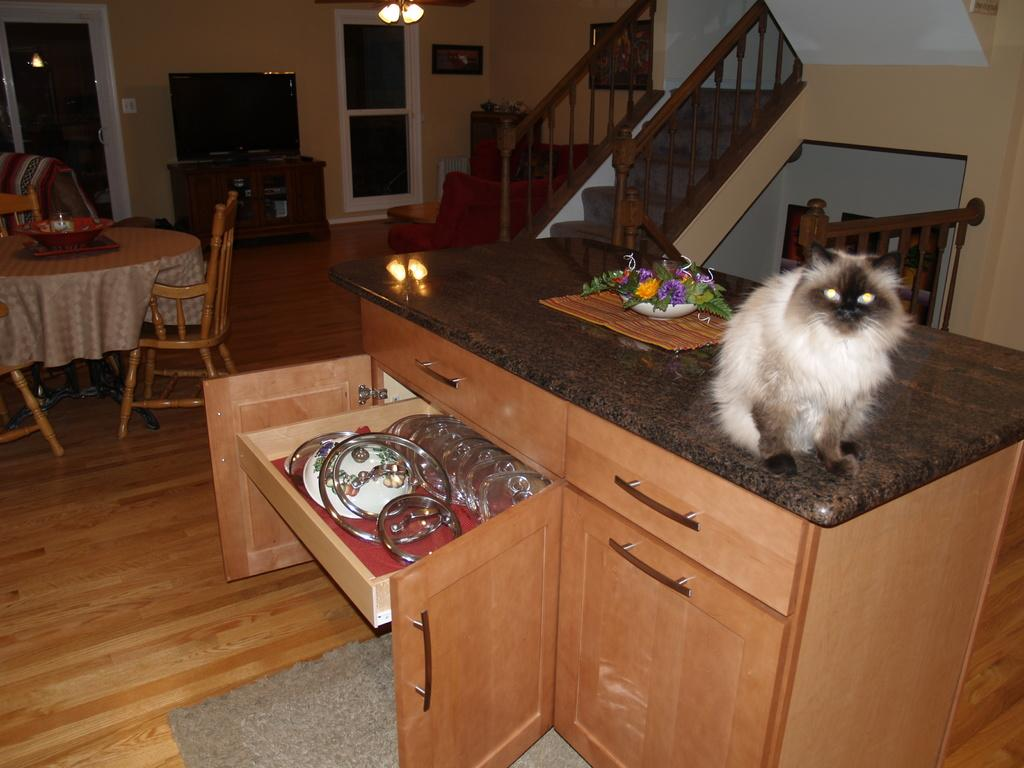What type of animal can be seen in the image? There is a cat in the image. What is located on the table in the image? There is a bowl with flowers in it on a table. What type of furniture is present in the image? There are cupboards and a chair in the image. What can be seen in the background of the image? There is a dining table, a window, steps, a wall, and lights in the background of the image. How does the cat use its brain to solve a tramp's beginner-level puzzle in the image? There is no tramp or puzzle present in the image, and the cat's brain is not depicted or discussed. 